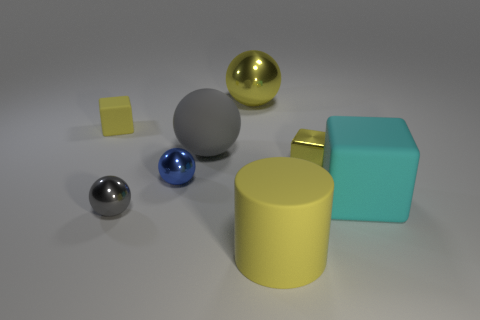What number of yellow metallic things have the same size as the gray rubber ball?
Give a very brief answer. 1. What number of yellow matte objects are there?
Make the answer very short. 2. Is the tiny gray thing made of the same material as the tiny yellow object that is behind the gray matte thing?
Keep it short and to the point. No. How many red objects are balls or shiny spheres?
Make the answer very short. 0. There is a yellow object that is the same material as the yellow ball; what size is it?
Give a very brief answer. Small. What number of gray matte things are the same shape as the blue object?
Keep it short and to the point. 1. Is the number of rubber balls that are right of the tiny yellow rubber thing greater than the number of small spheres that are to the left of the gray metallic thing?
Keep it short and to the point. Yes. Do the big metallic ball and the rubber object that is in front of the big cyan thing have the same color?
Offer a terse response. Yes. What material is the other cube that is the same size as the shiny cube?
Your answer should be compact. Rubber. How many things are big yellow matte cylinders or matte things that are behind the big cylinder?
Your answer should be compact. 4. 